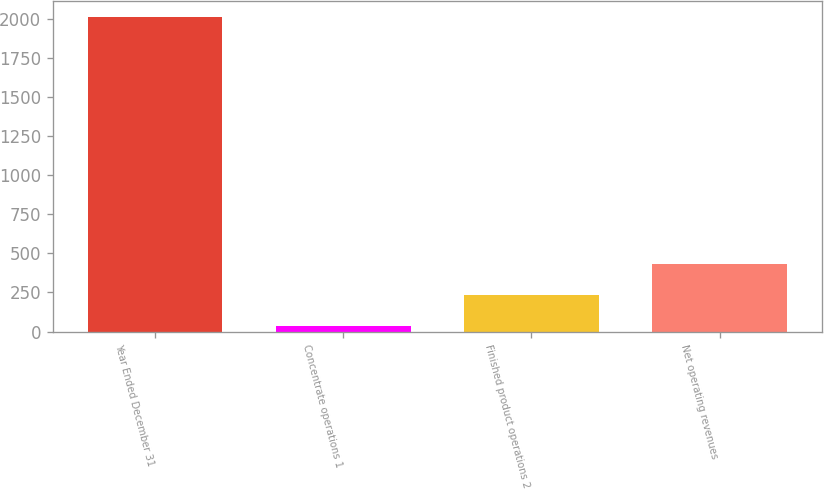<chart> <loc_0><loc_0><loc_500><loc_500><bar_chart><fcel>Year Ended December 31<fcel>Concentrate operations 1<fcel>Finished product operations 2<fcel>Net operating revenues<nl><fcel>2012<fcel>38<fcel>235.4<fcel>432.8<nl></chart> 